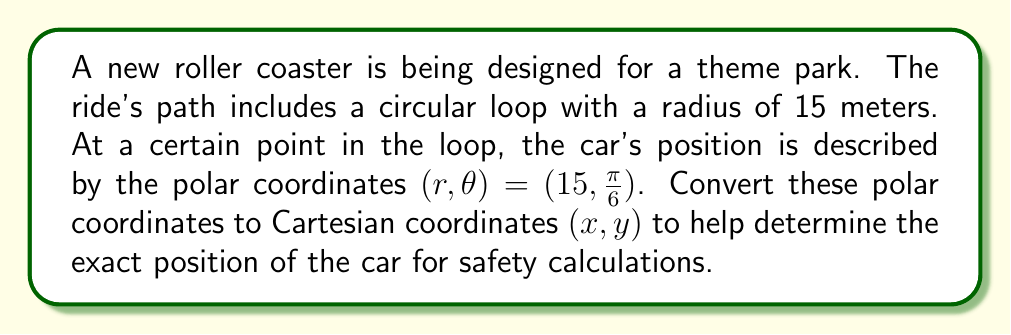Provide a solution to this math problem. To convert from polar coordinates $(r, \theta)$ to Cartesian coordinates $(x, y)$, we use the following formulas:

$$x = r \cos(\theta)$$
$$y = r \sin(\theta)$$

Given:
$r = 15$ meters
$\theta = \frac{\pi}{6}$ radians

Step 1: Calculate x-coordinate
$$x = r \cos(\theta) = 15 \cos(\frac{\pi}{6})$$

To evaluate this, recall that $\cos(\frac{\pi}{6}) = \frac{\sqrt{3}}{2}$

$$x = 15 \cdot \frac{\sqrt{3}}{2} = \frac{15\sqrt{3}}{2} \approx 12.99 \text{ meters}$$

Step 2: Calculate y-coordinate
$$y = r \sin(\theta) = 15 \sin(\frac{\pi}{6})$$

To evaluate this, recall that $\sin(\frac{\pi}{6}) = \frac{1}{2}$

$$y = 15 \cdot \frac{1}{2} = 7.5 \text{ meters}$$

Therefore, the Cartesian coordinates are $(x, y) = (\frac{15\sqrt{3}}{2}, 7.5)$ or approximately $(12.99, 7.5)$ meters.

[asy]
import geometry;

size(200);
draw(circle((0,0),15));
draw((-16,0)--(16,0),Arrow);
draw((0,-16)--(0,16),Arrow);
dot((15*sqrt(3)/2,7.5),red);
draw((0,0)--(15*sqrt(3)/2,7.5),red,Arrow);
label("$x$",(16,0),E);
label("$y$",(0,16),N);
label("$(x,y)$",(15*sqrt(3)/2,7.5),NE);
label("$r$",(7.5*sqrt(3)/2,3.75),NW);
label("$\theta$",(2,0),N);
[/asy]
Answer: The Cartesian coordinates are $(x, y) = (\frac{15\sqrt{3}}{2}, 7.5)$ meters, or approximately $(12.99, 7.5)$ meters. 